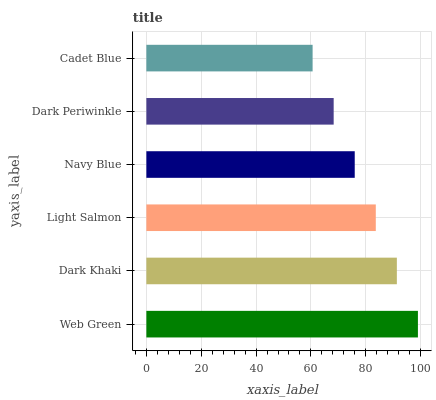Is Cadet Blue the minimum?
Answer yes or no. Yes. Is Web Green the maximum?
Answer yes or no. Yes. Is Dark Khaki the minimum?
Answer yes or no. No. Is Dark Khaki the maximum?
Answer yes or no. No. Is Web Green greater than Dark Khaki?
Answer yes or no. Yes. Is Dark Khaki less than Web Green?
Answer yes or no. Yes. Is Dark Khaki greater than Web Green?
Answer yes or no. No. Is Web Green less than Dark Khaki?
Answer yes or no. No. Is Light Salmon the high median?
Answer yes or no. Yes. Is Navy Blue the low median?
Answer yes or no. Yes. Is Dark Khaki the high median?
Answer yes or no. No. Is Dark Periwinkle the low median?
Answer yes or no. No. 